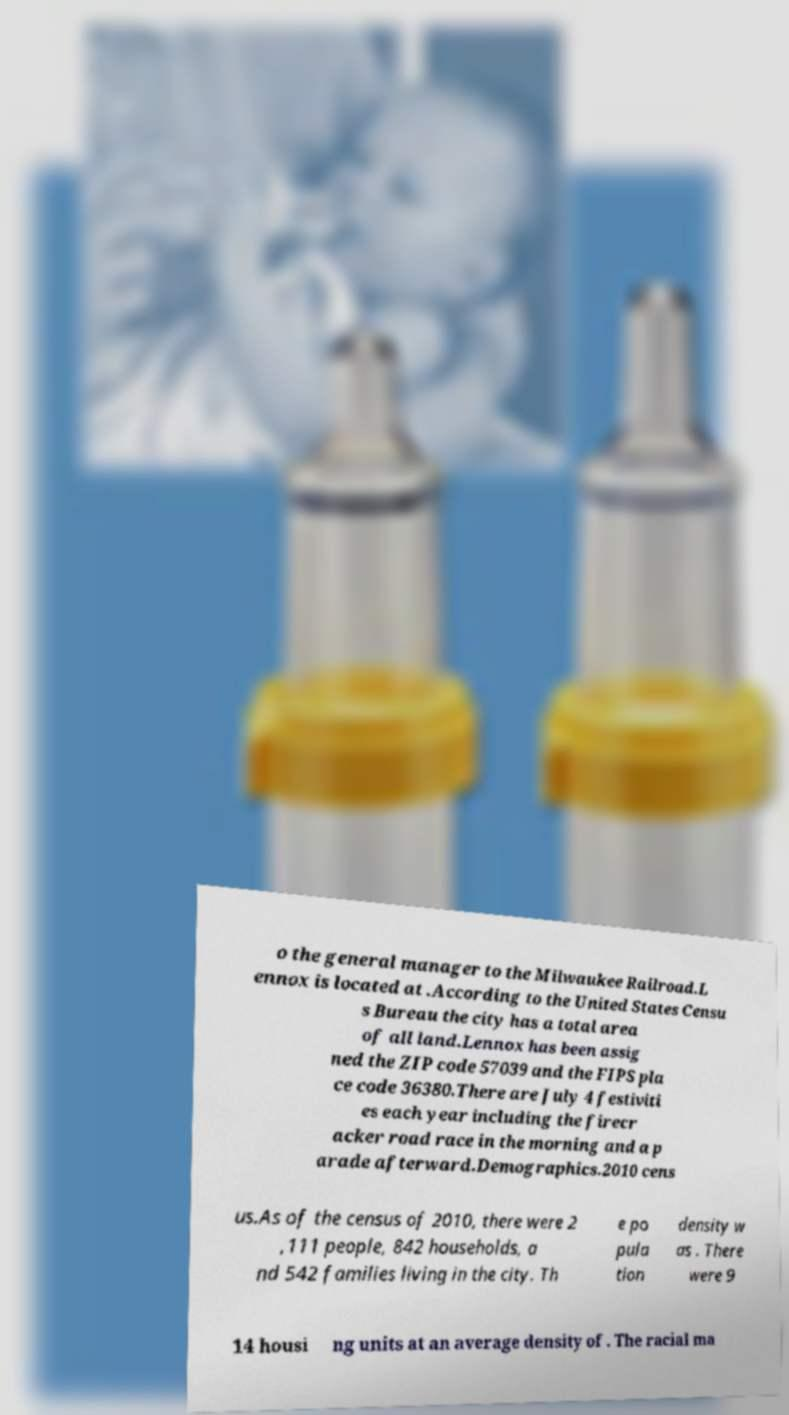I need the written content from this picture converted into text. Can you do that? o the general manager to the Milwaukee Railroad.L ennox is located at .According to the United States Censu s Bureau the city has a total area of all land.Lennox has been assig ned the ZIP code 57039 and the FIPS pla ce code 36380.There are July 4 festiviti es each year including the firecr acker road race in the morning and a p arade afterward.Demographics.2010 cens us.As of the census of 2010, there were 2 ,111 people, 842 households, a nd 542 families living in the city. Th e po pula tion density w as . There were 9 14 housi ng units at an average density of . The racial ma 